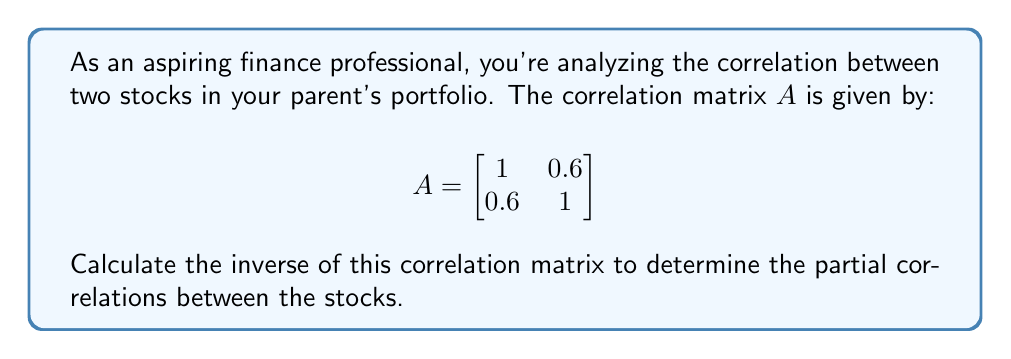Could you help me with this problem? To find the inverse of matrix $A$, we'll follow these steps:

1) For a 2x2 matrix $\begin{bmatrix} a & b \\ c & d \end{bmatrix}$, the inverse is given by:

   $$\frac{1}{ad-bc} \begin{bmatrix} d & -b \\ -c & a \end{bmatrix}$$

2) In our case, $a=1$, $b=0.6$, $c=0.6$, and $d=1$

3) Calculate the determinant:
   $ad-bc = (1)(1) - (0.6)(0.6) = 1 - 0.36 = 0.64$

4) Now, we can construct the inverse:

   $$A^{-1} = \frac{1}{0.64} \begin{bmatrix} 1 & -0.6 \\ -0.6 & 1 \end{bmatrix}$$

5) Simplify by dividing each element by 0.64:

   $$A^{-1} = \begin{bmatrix} 1.5625 & -0.9375 \\ -0.9375 & 1.5625 \end{bmatrix}$$

The inverse matrix represents the partial correlations between the stocks, accounting for the influence of other variables in the system.
Answer: $$A^{-1} = \begin{bmatrix} 1.5625 & -0.9375 \\ -0.9375 & 1.5625 \end{bmatrix}$$ 